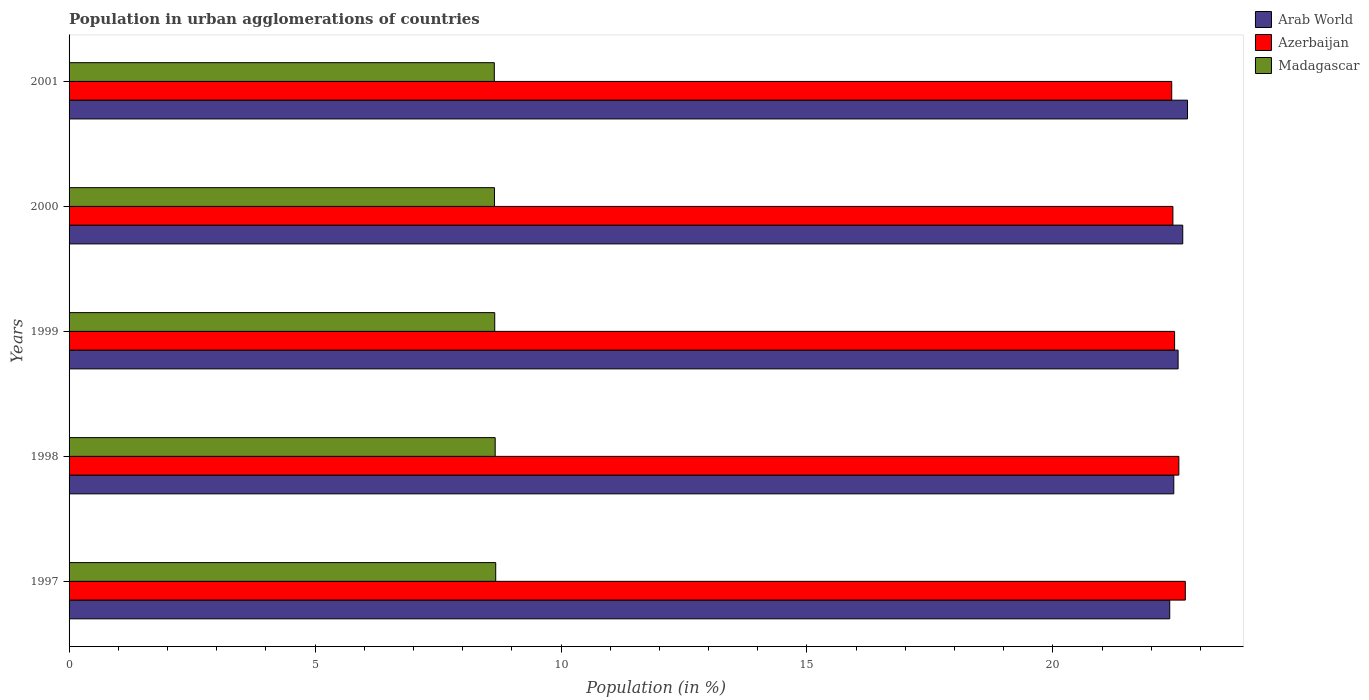How many bars are there on the 1st tick from the top?
Make the answer very short. 3. What is the percentage of population in urban agglomerations in Azerbaijan in 1997?
Keep it short and to the point. 22.69. Across all years, what is the maximum percentage of population in urban agglomerations in Arab World?
Offer a very short reply. 22.74. Across all years, what is the minimum percentage of population in urban agglomerations in Madagascar?
Offer a very short reply. 8.64. What is the total percentage of population in urban agglomerations in Arab World in the graph?
Offer a very short reply. 112.75. What is the difference between the percentage of population in urban agglomerations in Arab World in 2000 and that in 2001?
Your answer should be very brief. -0.1. What is the difference between the percentage of population in urban agglomerations in Arab World in 2000 and the percentage of population in urban agglomerations in Madagascar in 2001?
Give a very brief answer. 13.99. What is the average percentage of population in urban agglomerations in Azerbaijan per year?
Give a very brief answer. 22.51. In the year 2001, what is the difference between the percentage of population in urban agglomerations in Azerbaijan and percentage of population in urban agglomerations in Madagascar?
Make the answer very short. 13.77. In how many years, is the percentage of population in urban agglomerations in Arab World greater than 4 %?
Make the answer very short. 5. What is the ratio of the percentage of population in urban agglomerations in Madagascar in 1998 to that in 2000?
Keep it short and to the point. 1. Is the percentage of population in urban agglomerations in Azerbaijan in 1999 less than that in 2001?
Provide a short and direct response. No. What is the difference between the highest and the second highest percentage of population in urban agglomerations in Arab World?
Provide a short and direct response. 0.1. What is the difference between the highest and the lowest percentage of population in urban agglomerations in Madagascar?
Offer a very short reply. 0.03. Is the sum of the percentage of population in urban agglomerations in Madagascar in 1997 and 1998 greater than the maximum percentage of population in urban agglomerations in Azerbaijan across all years?
Offer a terse response. No. What does the 2nd bar from the top in 1999 represents?
Ensure brevity in your answer.  Azerbaijan. What does the 2nd bar from the bottom in 1998 represents?
Your response must be concise. Azerbaijan. Is it the case that in every year, the sum of the percentage of population in urban agglomerations in Madagascar and percentage of population in urban agglomerations in Arab World is greater than the percentage of population in urban agglomerations in Azerbaijan?
Your answer should be compact. Yes. How many bars are there?
Offer a terse response. 15. Are all the bars in the graph horizontal?
Your response must be concise. Yes. What is the difference between two consecutive major ticks on the X-axis?
Your response must be concise. 5. Are the values on the major ticks of X-axis written in scientific E-notation?
Provide a succinct answer. No. Does the graph contain any zero values?
Offer a terse response. No. Does the graph contain grids?
Offer a very short reply. No. How many legend labels are there?
Keep it short and to the point. 3. What is the title of the graph?
Ensure brevity in your answer.  Population in urban agglomerations of countries. What is the label or title of the X-axis?
Provide a short and direct response. Population (in %). What is the Population (in %) in Arab World in 1997?
Your answer should be compact. 22.37. What is the Population (in %) in Azerbaijan in 1997?
Your answer should be compact. 22.69. What is the Population (in %) of Madagascar in 1997?
Ensure brevity in your answer.  8.67. What is the Population (in %) of Arab World in 1998?
Give a very brief answer. 22.46. What is the Population (in %) of Azerbaijan in 1998?
Your response must be concise. 22.56. What is the Population (in %) in Madagascar in 1998?
Your response must be concise. 8.66. What is the Population (in %) in Arab World in 1999?
Give a very brief answer. 22.54. What is the Population (in %) in Azerbaijan in 1999?
Your answer should be compact. 22.47. What is the Population (in %) in Madagascar in 1999?
Keep it short and to the point. 8.65. What is the Population (in %) in Arab World in 2000?
Make the answer very short. 22.64. What is the Population (in %) in Azerbaijan in 2000?
Keep it short and to the point. 22.44. What is the Population (in %) in Madagascar in 2000?
Provide a short and direct response. 8.65. What is the Population (in %) of Arab World in 2001?
Provide a succinct answer. 22.74. What is the Population (in %) of Azerbaijan in 2001?
Provide a short and direct response. 22.41. What is the Population (in %) in Madagascar in 2001?
Offer a very short reply. 8.64. Across all years, what is the maximum Population (in %) in Arab World?
Keep it short and to the point. 22.74. Across all years, what is the maximum Population (in %) of Azerbaijan?
Provide a short and direct response. 22.69. Across all years, what is the maximum Population (in %) in Madagascar?
Make the answer very short. 8.67. Across all years, what is the minimum Population (in %) of Arab World?
Keep it short and to the point. 22.37. Across all years, what is the minimum Population (in %) in Azerbaijan?
Give a very brief answer. 22.41. Across all years, what is the minimum Population (in %) of Madagascar?
Your response must be concise. 8.64. What is the total Population (in %) of Arab World in the graph?
Your response must be concise. 112.75. What is the total Population (in %) in Azerbaijan in the graph?
Your answer should be compact. 112.57. What is the total Population (in %) of Madagascar in the graph?
Your answer should be compact. 43.28. What is the difference between the Population (in %) of Arab World in 1997 and that in 1998?
Your response must be concise. -0.08. What is the difference between the Population (in %) of Azerbaijan in 1997 and that in 1998?
Your answer should be compact. 0.13. What is the difference between the Population (in %) of Madagascar in 1997 and that in 1998?
Keep it short and to the point. 0.01. What is the difference between the Population (in %) in Arab World in 1997 and that in 1999?
Your response must be concise. -0.17. What is the difference between the Population (in %) in Azerbaijan in 1997 and that in 1999?
Ensure brevity in your answer.  0.22. What is the difference between the Population (in %) of Madagascar in 1997 and that in 1999?
Provide a short and direct response. 0.02. What is the difference between the Population (in %) in Arab World in 1997 and that in 2000?
Offer a very short reply. -0.26. What is the difference between the Population (in %) of Azerbaijan in 1997 and that in 2000?
Your response must be concise. 0.25. What is the difference between the Population (in %) of Madagascar in 1997 and that in 2000?
Your answer should be compact. 0.03. What is the difference between the Population (in %) in Arab World in 1997 and that in 2001?
Keep it short and to the point. -0.36. What is the difference between the Population (in %) of Azerbaijan in 1997 and that in 2001?
Give a very brief answer. 0.28. What is the difference between the Population (in %) of Madagascar in 1997 and that in 2001?
Offer a very short reply. 0.03. What is the difference between the Population (in %) of Arab World in 1998 and that in 1999?
Offer a very short reply. -0.09. What is the difference between the Population (in %) in Azerbaijan in 1998 and that in 1999?
Your answer should be very brief. 0.09. What is the difference between the Population (in %) of Madagascar in 1998 and that in 1999?
Give a very brief answer. 0.01. What is the difference between the Population (in %) of Arab World in 1998 and that in 2000?
Keep it short and to the point. -0.18. What is the difference between the Population (in %) in Azerbaijan in 1998 and that in 2000?
Provide a short and direct response. 0.12. What is the difference between the Population (in %) of Madagascar in 1998 and that in 2000?
Your answer should be very brief. 0.01. What is the difference between the Population (in %) of Arab World in 1998 and that in 2001?
Ensure brevity in your answer.  -0.28. What is the difference between the Population (in %) of Azerbaijan in 1998 and that in 2001?
Keep it short and to the point. 0.14. What is the difference between the Population (in %) in Madagascar in 1998 and that in 2001?
Make the answer very short. 0.02. What is the difference between the Population (in %) in Arab World in 1999 and that in 2000?
Offer a terse response. -0.09. What is the difference between the Population (in %) in Azerbaijan in 1999 and that in 2000?
Give a very brief answer. 0.03. What is the difference between the Population (in %) of Madagascar in 1999 and that in 2000?
Give a very brief answer. 0.01. What is the difference between the Population (in %) in Arab World in 1999 and that in 2001?
Your response must be concise. -0.19. What is the difference between the Population (in %) in Azerbaijan in 1999 and that in 2001?
Make the answer very short. 0.06. What is the difference between the Population (in %) of Madagascar in 1999 and that in 2001?
Your response must be concise. 0.01. What is the difference between the Population (in %) in Arab World in 2000 and that in 2001?
Keep it short and to the point. -0.1. What is the difference between the Population (in %) of Azerbaijan in 2000 and that in 2001?
Provide a short and direct response. 0.02. What is the difference between the Population (in %) of Madagascar in 2000 and that in 2001?
Offer a very short reply. 0. What is the difference between the Population (in %) of Arab World in 1997 and the Population (in %) of Azerbaijan in 1998?
Offer a terse response. -0.19. What is the difference between the Population (in %) in Arab World in 1997 and the Population (in %) in Madagascar in 1998?
Keep it short and to the point. 13.71. What is the difference between the Population (in %) in Azerbaijan in 1997 and the Population (in %) in Madagascar in 1998?
Provide a short and direct response. 14.03. What is the difference between the Population (in %) in Arab World in 1997 and the Population (in %) in Azerbaijan in 1999?
Offer a very short reply. -0.1. What is the difference between the Population (in %) of Arab World in 1997 and the Population (in %) of Madagascar in 1999?
Keep it short and to the point. 13.72. What is the difference between the Population (in %) in Azerbaijan in 1997 and the Population (in %) in Madagascar in 1999?
Make the answer very short. 14.04. What is the difference between the Population (in %) in Arab World in 1997 and the Population (in %) in Azerbaijan in 2000?
Your answer should be very brief. -0.06. What is the difference between the Population (in %) in Arab World in 1997 and the Population (in %) in Madagascar in 2000?
Offer a very short reply. 13.73. What is the difference between the Population (in %) in Azerbaijan in 1997 and the Population (in %) in Madagascar in 2000?
Offer a terse response. 14.04. What is the difference between the Population (in %) in Arab World in 1997 and the Population (in %) in Azerbaijan in 2001?
Offer a terse response. -0.04. What is the difference between the Population (in %) of Arab World in 1997 and the Population (in %) of Madagascar in 2001?
Your response must be concise. 13.73. What is the difference between the Population (in %) in Azerbaijan in 1997 and the Population (in %) in Madagascar in 2001?
Provide a succinct answer. 14.05. What is the difference between the Population (in %) of Arab World in 1998 and the Population (in %) of Azerbaijan in 1999?
Offer a very short reply. -0.02. What is the difference between the Population (in %) of Arab World in 1998 and the Population (in %) of Madagascar in 1999?
Provide a short and direct response. 13.8. What is the difference between the Population (in %) of Azerbaijan in 1998 and the Population (in %) of Madagascar in 1999?
Provide a succinct answer. 13.91. What is the difference between the Population (in %) of Arab World in 1998 and the Population (in %) of Azerbaijan in 2000?
Keep it short and to the point. 0.02. What is the difference between the Population (in %) in Arab World in 1998 and the Population (in %) in Madagascar in 2000?
Your response must be concise. 13.81. What is the difference between the Population (in %) of Azerbaijan in 1998 and the Population (in %) of Madagascar in 2000?
Make the answer very short. 13.91. What is the difference between the Population (in %) in Arab World in 1998 and the Population (in %) in Azerbaijan in 2001?
Provide a succinct answer. 0.04. What is the difference between the Population (in %) of Arab World in 1998 and the Population (in %) of Madagascar in 2001?
Ensure brevity in your answer.  13.81. What is the difference between the Population (in %) in Azerbaijan in 1998 and the Population (in %) in Madagascar in 2001?
Your response must be concise. 13.91. What is the difference between the Population (in %) in Arab World in 1999 and the Population (in %) in Azerbaijan in 2000?
Offer a very short reply. 0.11. What is the difference between the Population (in %) in Arab World in 1999 and the Population (in %) in Madagascar in 2000?
Provide a short and direct response. 13.9. What is the difference between the Population (in %) in Azerbaijan in 1999 and the Population (in %) in Madagascar in 2000?
Give a very brief answer. 13.83. What is the difference between the Population (in %) of Arab World in 1999 and the Population (in %) of Azerbaijan in 2001?
Provide a succinct answer. 0.13. What is the difference between the Population (in %) in Arab World in 1999 and the Population (in %) in Madagascar in 2001?
Provide a short and direct response. 13.9. What is the difference between the Population (in %) of Azerbaijan in 1999 and the Population (in %) of Madagascar in 2001?
Give a very brief answer. 13.83. What is the difference between the Population (in %) of Arab World in 2000 and the Population (in %) of Azerbaijan in 2001?
Your answer should be compact. 0.22. What is the difference between the Population (in %) of Arab World in 2000 and the Population (in %) of Madagascar in 2001?
Keep it short and to the point. 13.99. What is the difference between the Population (in %) in Azerbaijan in 2000 and the Population (in %) in Madagascar in 2001?
Provide a short and direct response. 13.79. What is the average Population (in %) of Arab World per year?
Give a very brief answer. 22.55. What is the average Population (in %) of Azerbaijan per year?
Offer a very short reply. 22.52. What is the average Population (in %) of Madagascar per year?
Your answer should be compact. 8.66. In the year 1997, what is the difference between the Population (in %) of Arab World and Population (in %) of Azerbaijan?
Ensure brevity in your answer.  -0.32. In the year 1997, what is the difference between the Population (in %) of Arab World and Population (in %) of Madagascar?
Provide a succinct answer. 13.7. In the year 1997, what is the difference between the Population (in %) in Azerbaijan and Population (in %) in Madagascar?
Offer a terse response. 14.02. In the year 1998, what is the difference between the Population (in %) in Arab World and Population (in %) in Azerbaijan?
Keep it short and to the point. -0.1. In the year 1998, what is the difference between the Population (in %) in Arab World and Population (in %) in Madagascar?
Keep it short and to the point. 13.79. In the year 1998, what is the difference between the Population (in %) of Azerbaijan and Population (in %) of Madagascar?
Provide a short and direct response. 13.9. In the year 1999, what is the difference between the Population (in %) in Arab World and Population (in %) in Azerbaijan?
Provide a short and direct response. 0.07. In the year 1999, what is the difference between the Population (in %) in Arab World and Population (in %) in Madagascar?
Your response must be concise. 13.89. In the year 1999, what is the difference between the Population (in %) in Azerbaijan and Population (in %) in Madagascar?
Give a very brief answer. 13.82. In the year 2000, what is the difference between the Population (in %) in Arab World and Population (in %) in Azerbaijan?
Offer a very short reply. 0.2. In the year 2000, what is the difference between the Population (in %) in Arab World and Population (in %) in Madagascar?
Your answer should be very brief. 13.99. In the year 2000, what is the difference between the Population (in %) in Azerbaijan and Population (in %) in Madagascar?
Your answer should be compact. 13.79. In the year 2001, what is the difference between the Population (in %) in Arab World and Population (in %) in Azerbaijan?
Keep it short and to the point. 0.32. In the year 2001, what is the difference between the Population (in %) of Arab World and Population (in %) of Madagascar?
Keep it short and to the point. 14.09. In the year 2001, what is the difference between the Population (in %) in Azerbaijan and Population (in %) in Madagascar?
Give a very brief answer. 13.77. What is the ratio of the Population (in %) of Azerbaijan in 1997 to that in 1998?
Your answer should be very brief. 1.01. What is the ratio of the Population (in %) in Madagascar in 1997 to that in 1998?
Give a very brief answer. 1. What is the ratio of the Population (in %) in Azerbaijan in 1997 to that in 1999?
Provide a succinct answer. 1.01. What is the ratio of the Population (in %) of Madagascar in 1997 to that in 1999?
Your response must be concise. 1. What is the ratio of the Population (in %) of Arab World in 1997 to that in 2000?
Offer a very short reply. 0.99. What is the ratio of the Population (in %) in Azerbaijan in 1997 to that in 2000?
Your response must be concise. 1.01. What is the ratio of the Population (in %) of Madagascar in 1997 to that in 2000?
Your answer should be compact. 1. What is the ratio of the Population (in %) of Arab World in 1997 to that in 2001?
Provide a short and direct response. 0.98. What is the ratio of the Population (in %) of Azerbaijan in 1997 to that in 2001?
Ensure brevity in your answer.  1.01. What is the ratio of the Population (in %) of Madagascar in 1997 to that in 2001?
Keep it short and to the point. 1. What is the ratio of the Population (in %) of Arab World in 1998 to that in 1999?
Offer a very short reply. 1. What is the ratio of the Population (in %) of Arab World in 1998 to that in 2000?
Provide a short and direct response. 0.99. What is the ratio of the Population (in %) of Azerbaijan in 1998 to that in 2000?
Keep it short and to the point. 1.01. What is the ratio of the Population (in %) in Madagascar in 1998 to that in 2000?
Keep it short and to the point. 1. What is the ratio of the Population (in %) in Arab World in 1998 to that in 2001?
Make the answer very short. 0.99. What is the ratio of the Population (in %) of Azerbaijan in 1999 to that in 2000?
Provide a short and direct response. 1. What is the ratio of the Population (in %) in Madagascar in 1999 to that in 2000?
Your answer should be very brief. 1. What is the ratio of the Population (in %) of Azerbaijan in 1999 to that in 2001?
Keep it short and to the point. 1. What is the ratio of the Population (in %) in Arab World in 2000 to that in 2001?
Provide a succinct answer. 1. What is the ratio of the Population (in %) of Azerbaijan in 2000 to that in 2001?
Ensure brevity in your answer.  1. What is the difference between the highest and the second highest Population (in %) of Arab World?
Offer a terse response. 0.1. What is the difference between the highest and the second highest Population (in %) in Azerbaijan?
Keep it short and to the point. 0.13. What is the difference between the highest and the second highest Population (in %) of Madagascar?
Provide a short and direct response. 0.01. What is the difference between the highest and the lowest Population (in %) of Arab World?
Provide a succinct answer. 0.36. What is the difference between the highest and the lowest Population (in %) of Azerbaijan?
Your answer should be very brief. 0.28. What is the difference between the highest and the lowest Population (in %) in Madagascar?
Make the answer very short. 0.03. 